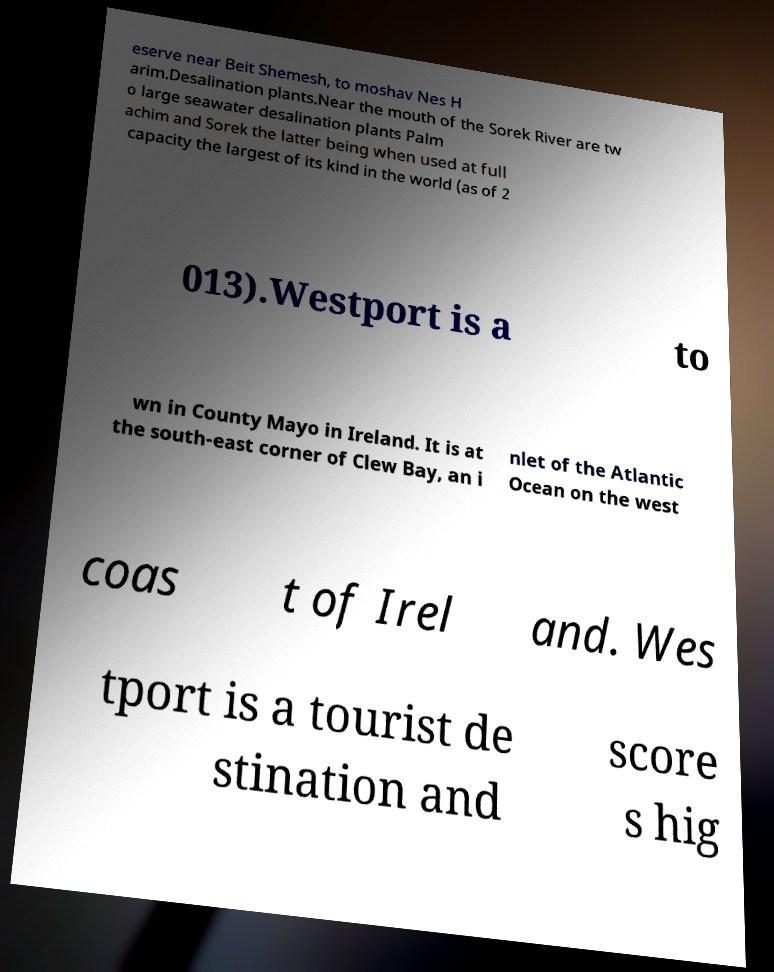Please read and relay the text visible in this image. What does it say? eserve near Beit Shemesh, to moshav Nes H arim.Desalination plants.Near the mouth of the Sorek River are tw o large seawater desalination plants Palm achim and Sorek the latter being when used at full capacity the largest of its kind in the world (as of 2 013).Westport is a to wn in County Mayo in Ireland. It is at the south-east corner of Clew Bay, an i nlet of the Atlantic Ocean on the west coas t of Irel and. Wes tport is a tourist de stination and score s hig 